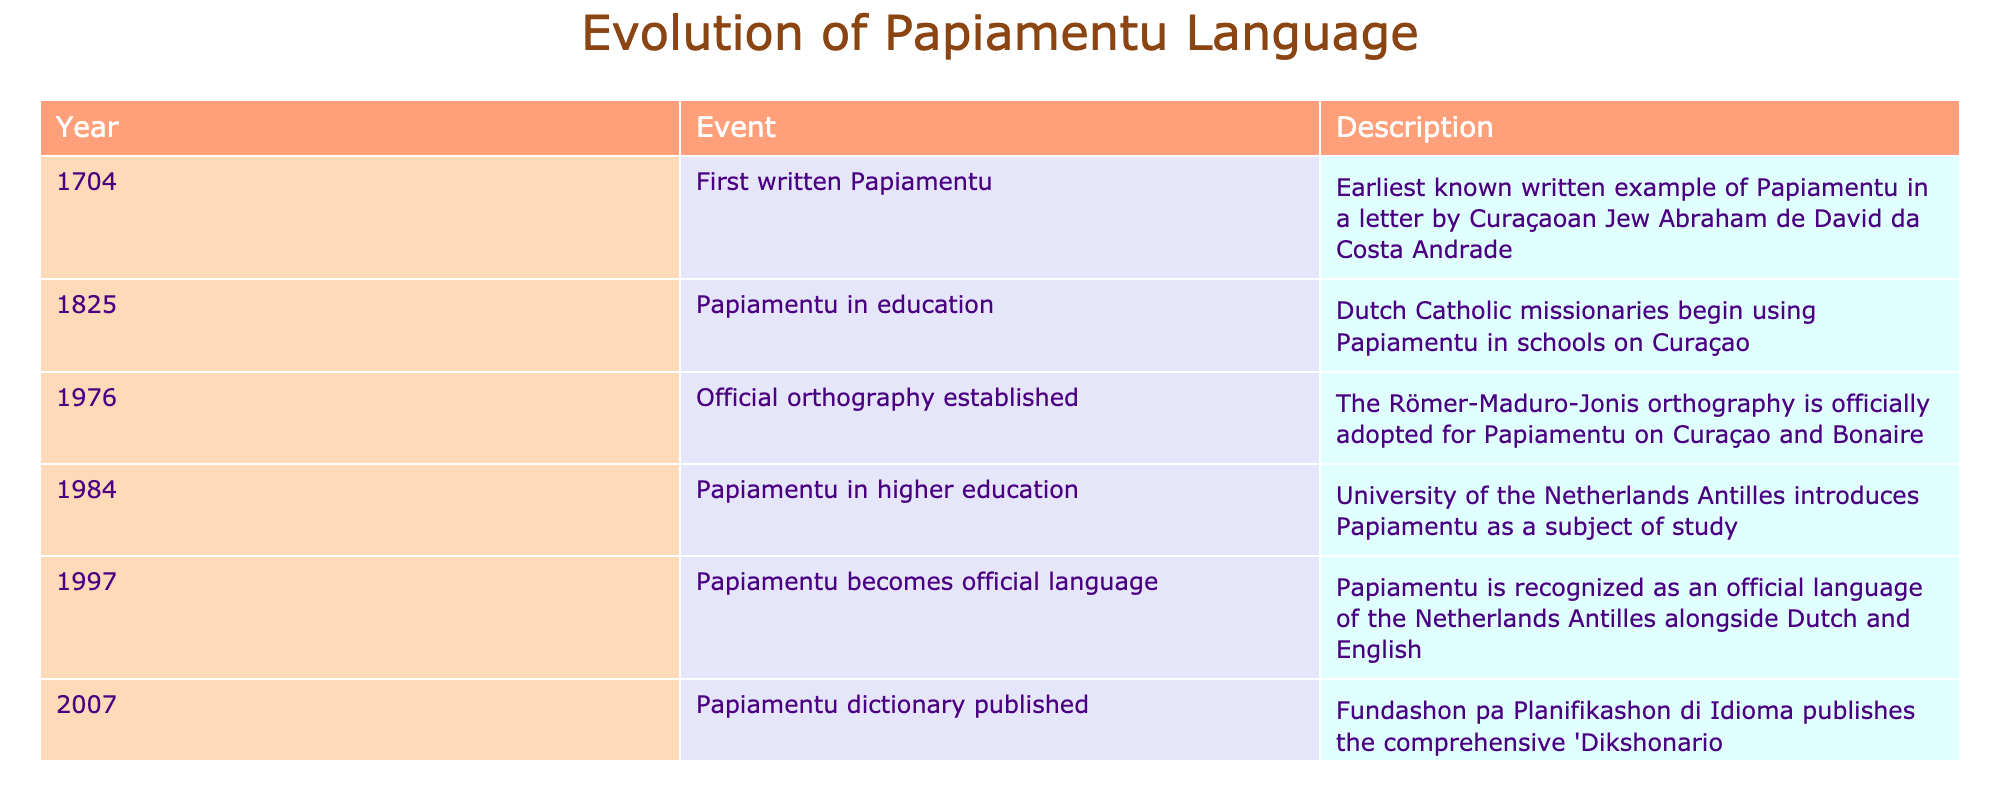What is the earliest event listed in the table? The earliest event is from the year 1704. It states that this is the first written example of Papiamentu.
Answer: 1704 In which year was Papiamentu recognized as an official language? The table indicates that Papiamentu was recognized as an official language in 1997.
Answer: 1997 How many events occurred in the 20th century? Two events occurred in the 20th century: the establishment of the official orthography in 1976 and the recognition of Papiamentu as an official language in 1997.
Answer: 2 Was Papiamentu used in education before 1825? According to the table, Papiamentu was not used in education before 1825, as the first mention of its use in schools by Dutch Catholic missionaries is from that year.
Answer: No What is the time span in years from the first written example of Papiamentu to its inclusion in higher education? The first written example occurred in 1704 and it was included in higher education in 1984. The difference is calculated as 1984 - 1704 = 280 years.
Answer: 280 years What significant step for Papiamentu happened in 2007? In 2007, a comprehensive dictionary titled 'Dikshonario Papiamentu-Hulandes' was published, marking a significant development for the language.
Answer: Publication of a dictionary Did the use of Papiamentu in education precede the establishment of its official orthography? Yes, based on the table, Papiamentu was used in education starting in 1825, while the official orthography was established in 1976, which is after the education events.
Answer: Yes How many years are there between the adoption of the official orthography and the publication of the dictionary? The official orthography was established in 1976 and the dictionary was published in 2007. To find the difference: 2007 - 1976 = 31 years.
Answer: 31 years What important educational milestone occurred in 1984? In 1984, Papiamentu was introduced as a subject of study at the University of the Netherlands Antilles, which is an important educational milestone for the language.
Answer: Introduction in higher education 